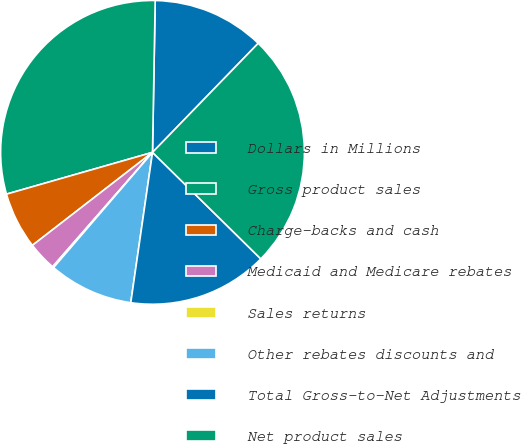Convert chart to OTSL. <chart><loc_0><loc_0><loc_500><loc_500><pie_chart><fcel>Dollars in Millions<fcel>Gross product sales<fcel>Charge-backs and cash<fcel>Medicaid and Medicare rebates<fcel>Sales returns<fcel>Other rebates discounts and<fcel>Total Gross-to-Net Adjustments<fcel>Net product sales<nl><fcel>11.97%<fcel>29.72%<fcel>6.05%<fcel>3.09%<fcel>0.13%<fcel>9.01%<fcel>14.92%<fcel>25.12%<nl></chart> 